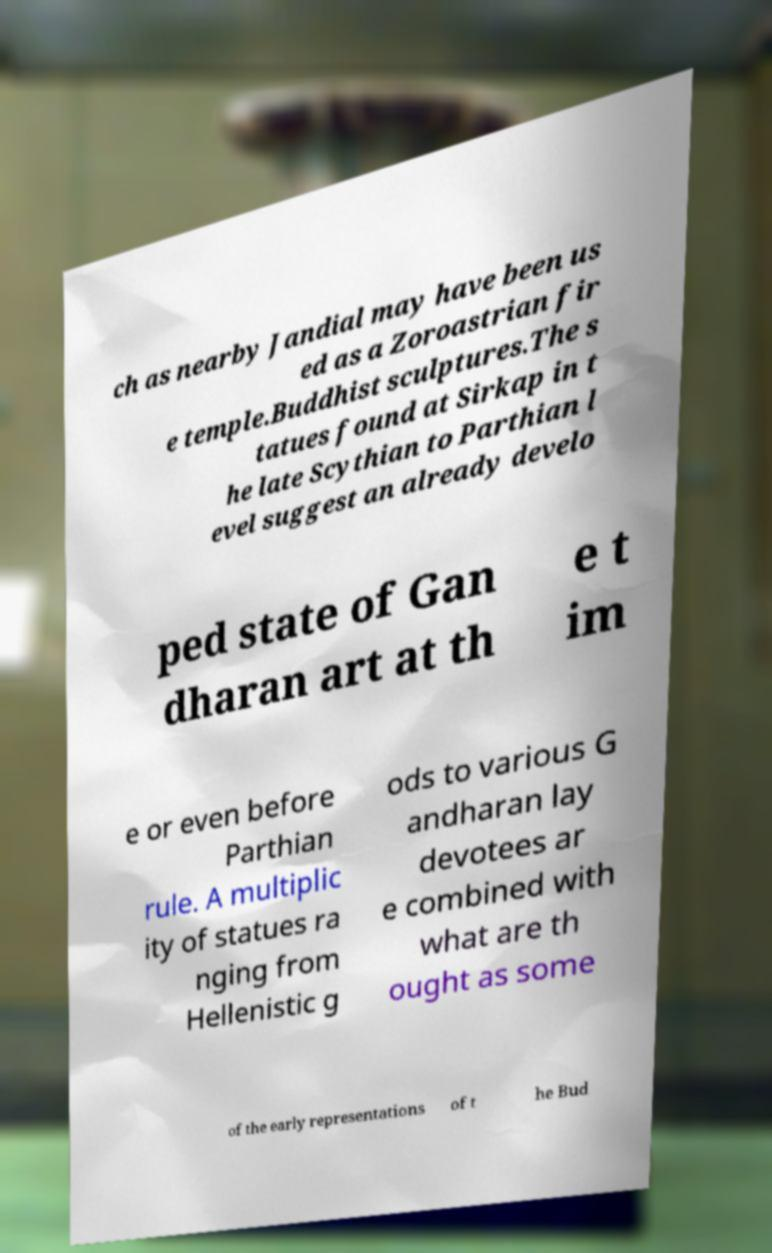Can you accurately transcribe the text from the provided image for me? ch as nearby Jandial may have been us ed as a Zoroastrian fir e temple.Buddhist sculptures.The s tatues found at Sirkap in t he late Scythian to Parthian l evel suggest an already develo ped state of Gan dharan art at th e t im e or even before Parthian rule. A multiplic ity of statues ra nging from Hellenistic g ods to various G andharan lay devotees ar e combined with what are th ought as some of the early representations of t he Bud 